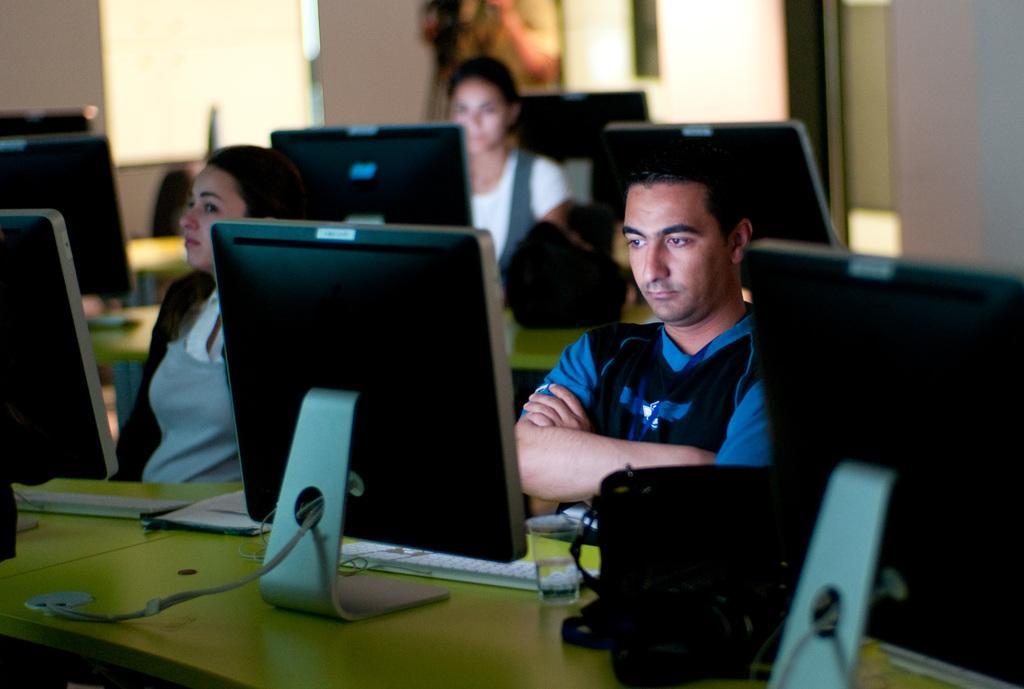Describe this image in one or two sentences. In this image we can see a man and woman. Man is wearing blue and black color t-shirt and woman is wearing grey color dress with black coat. In front of them, green table is there. On table we can see monitors, keyboards, glass bag and paper. Background of the image, one more woman is there and we can see five monitors. 